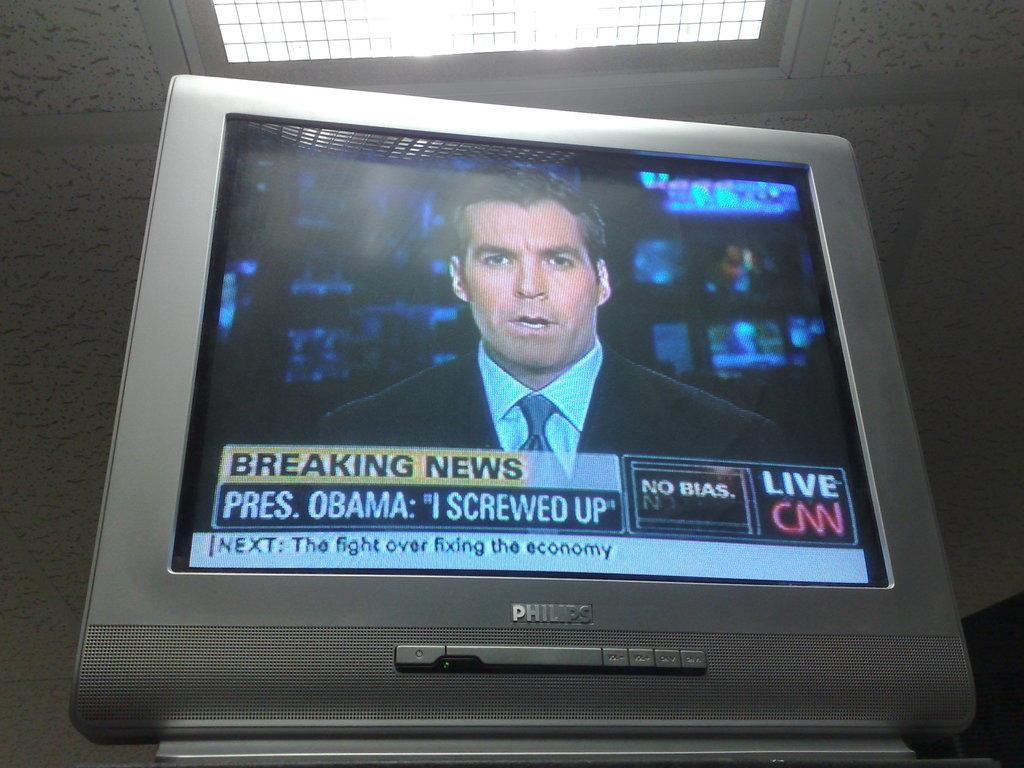<image>
Render a clear and concise summary of the photo. A television screen is on CNN Live and shows that there is breaking news. 